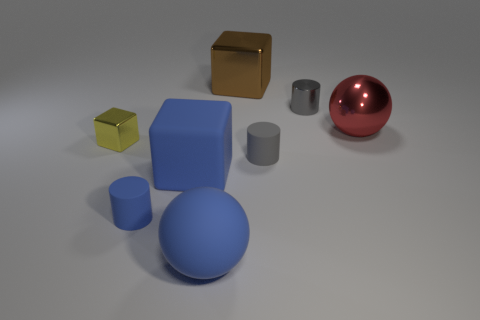Add 1 matte cylinders. How many objects exist? 9 Subtract all cylinders. How many objects are left? 5 Add 6 matte cylinders. How many matte cylinders are left? 8 Add 5 small shiny cubes. How many small shiny cubes exist? 6 Subtract 1 blue cubes. How many objects are left? 7 Subtract all big yellow shiny spheres. Subtract all large red balls. How many objects are left? 7 